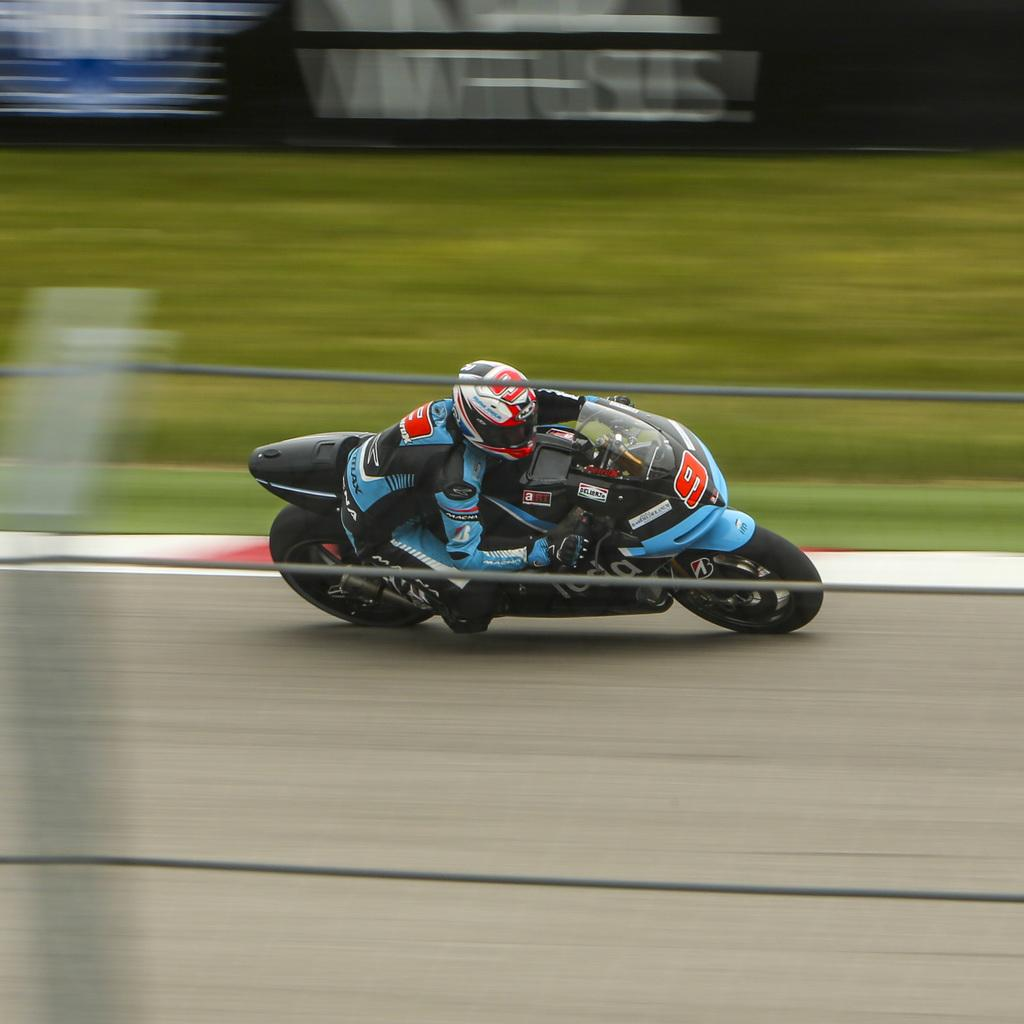What is the person in the image doing? There is a person riding a bike in the image. What objects can be seen near the person? Ropes are visible in the image. What type of surface is the person riding on? There is a road in the image. What type of decorations are present in the image? There are posters in the image. How would you describe the background of the image? The background of the image is blurred. What type of seed is being planted by the ducks in the image? There are no ducks or seeds present in the image. How does the sun affect the person riding the bike in the image? The image does not show the sun, so its effect on the person riding the bike cannot be determined. 